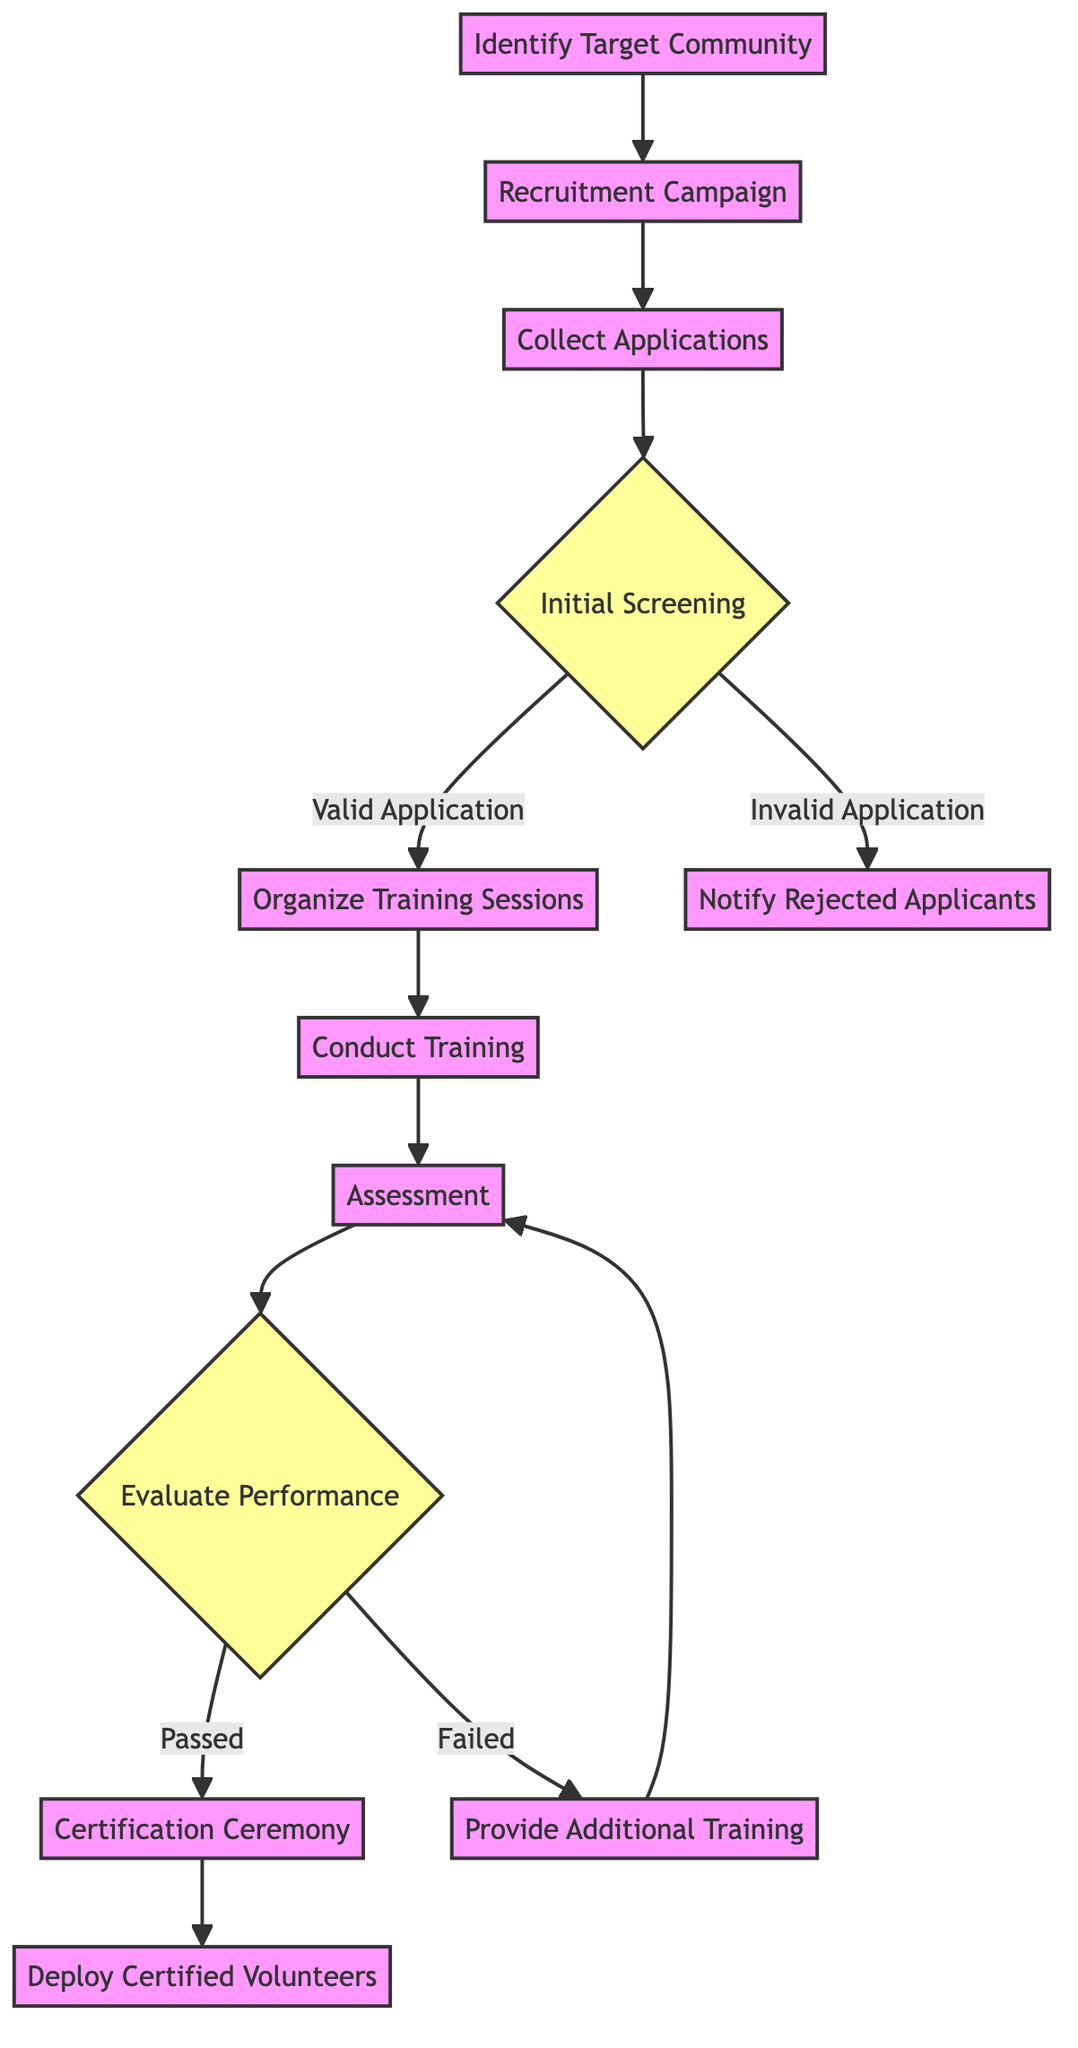What is the first activity in the diagram? The diagram starts with "Identify Target Community," which is the initial action node listed at the beginning of the flow.
Answer: Identify Target Community How many decision points are there in the diagram? The diagram contains two decision nodes: "Initial Screening" and "Evaluate Performance." Each represents a branch in the flow where different paths are taken based on specific conditions.
Answer: 2 What activity follows "Conduct Training"? The next activity that follows "Conduct Training" is "Assessment," which is the action where the skills and knowledge of the volunteers are evaluated.
Answer: Assessment What happens to rejected applicants? Rejected applicants receive notifications through "Notify Rejected Applicants," which is the action that communicates that they did not meet the eligibility criteria.
Answer: Notify Rejected Applicants What is the outcome if a volunteer passes the assessment? If a volunteer passes the assessment, the next step is "Certification Ceremony," where successful volunteers are awarded their certificates.
Answer: Certification Ceremony How many main actions are there in total? The diagram outlines a total of 10 distinct action activities without counting decision nodes, indicating the steps taken throughout the training process.
Answer: 10 What is the action taken for volunteers who fail the assessment? Volunteers who fail the assessment are given "Provide Additional Training," enabling them to improve their skills before reassessing.
Answer: Provide Additional Training Which activity leads to deploying certified volunteers? "Certification Ceremony" directly leads to the final activity, "Deploy Certified Volunteers," where newly certified individuals are integrated into healthcare roles.
Answer: Deploy Certified Volunteers 